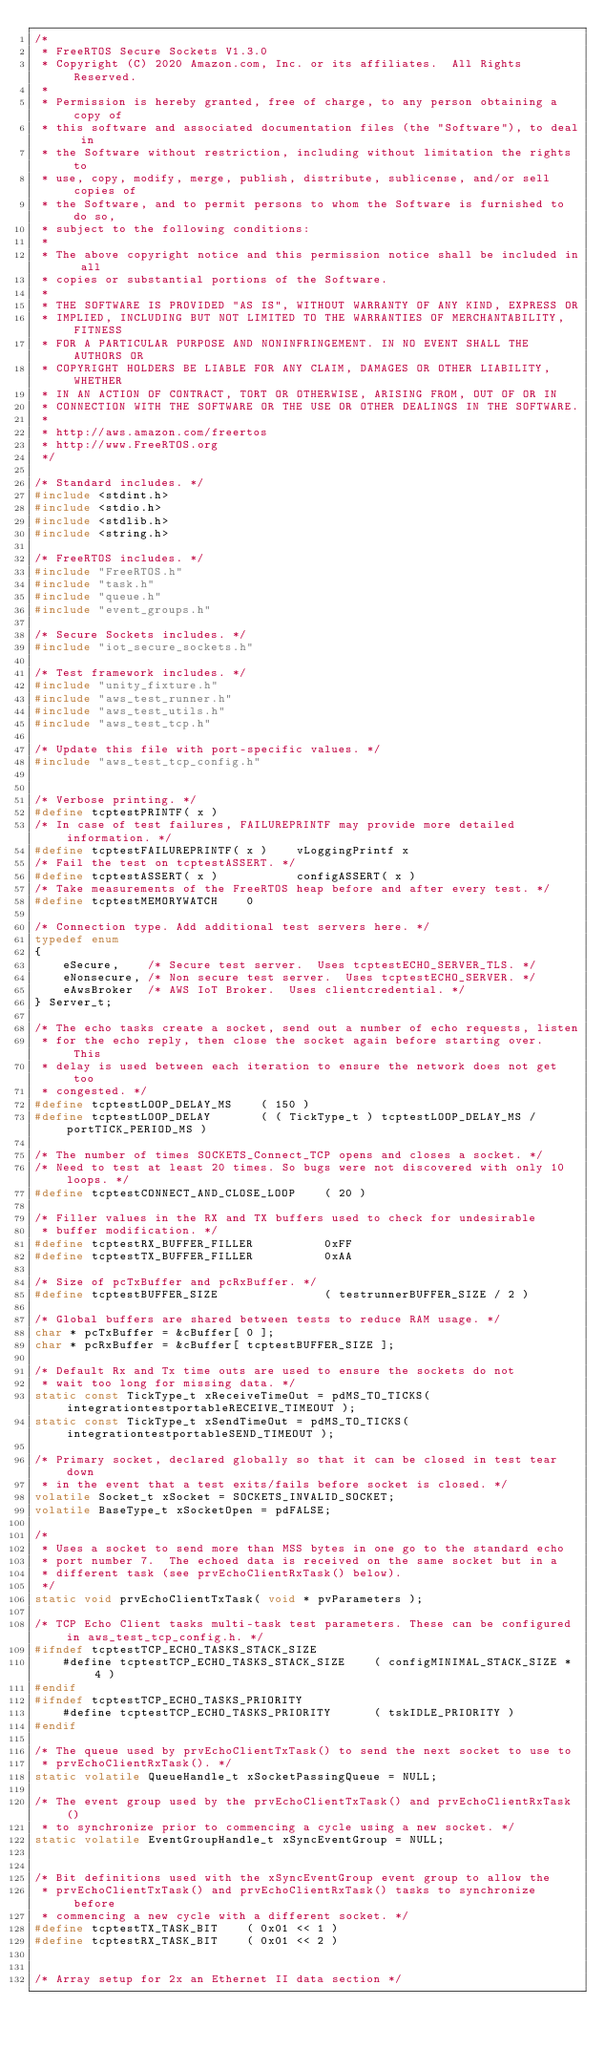Convert code to text. <code><loc_0><loc_0><loc_500><loc_500><_C_>/*
 * FreeRTOS Secure Sockets V1.3.0
 * Copyright (C) 2020 Amazon.com, Inc. or its affiliates.  All Rights Reserved.
 *
 * Permission is hereby granted, free of charge, to any person obtaining a copy of
 * this software and associated documentation files (the "Software"), to deal in
 * the Software without restriction, including without limitation the rights to
 * use, copy, modify, merge, publish, distribute, sublicense, and/or sell copies of
 * the Software, and to permit persons to whom the Software is furnished to do so,
 * subject to the following conditions:
 *
 * The above copyright notice and this permission notice shall be included in all
 * copies or substantial portions of the Software.
 *
 * THE SOFTWARE IS PROVIDED "AS IS", WITHOUT WARRANTY OF ANY KIND, EXPRESS OR
 * IMPLIED, INCLUDING BUT NOT LIMITED TO THE WARRANTIES OF MERCHANTABILITY, FITNESS
 * FOR A PARTICULAR PURPOSE AND NONINFRINGEMENT. IN NO EVENT SHALL THE AUTHORS OR
 * COPYRIGHT HOLDERS BE LIABLE FOR ANY CLAIM, DAMAGES OR OTHER LIABILITY, WHETHER
 * IN AN ACTION OF CONTRACT, TORT OR OTHERWISE, ARISING FROM, OUT OF OR IN
 * CONNECTION WITH THE SOFTWARE OR THE USE OR OTHER DEALINGS IN THE SOFTWARE.
 *
 * http://aws.amazon.com/freertos
 * http://www.FreeRTOS.org
 */

/* Standard includes. */
#include <stdint.h>
#include <stdio.h>
#include <stdlib.h>
#include <string.h>

/* FreeRTOS includes. */
#include "FreeRTOS.h"
#include "task.h"
#include "queue.h"
#include "event_groups.h"

/* Secure Sockets includes. */
#include "iot_secure_sockets.h"

/* Test framework includes. */
#include "unity_fixture.h"
#include "aws_test_runner.h"
#include "aws_test_utils.h"
#include "aws_test_tcp.h"

/* Update this file with port-specific values. */
#include "aws_test_tcp_config.h"


/* Verbose printing. */
#define tcptestPRINTF( x )
/* In case of test failures, FAILUREPRINTF may provide more detailed information. */
#define tcptestFAILUREPRINTF( x )    vLoggingPrintf x
/* Fail the test on tcptestASSERT. */
#define tcptestASSERT( x )           configASSERT( x )
/* Take measurements of the FreeRTOS heap before and after every test. */
#define tcptestMEMORYWATCH    0

/* Connection type. Add additional test servers here. */
typedef enum
{
    eSecure,    /* Secure test server.  Uses tcptestECHO_SERVER_TLS. */
    eNonsecure, /* Non secure test server.  Uses tcptestECHO_SERVER. */
    eAwsBroker  /* AWS IoT Broker.  Uses clientcredential. */
} Server_t;

/* The echo tasks create a socket, send out a number of echo requests, listen
 * for the echo reply, then close the socket again before starting over.  This
 * delay is used between each iteration to ensure the network does not get too
 * congested. */
#define tcptestLOOP_DELAY_MS    ( 150 )
#define tcptestLOOP_DELAY       ( ( TickType_t ) tcptestLOOP_DELAY_MS / portTICK_PERIOD_MS )

/* The number of times SOCKETS_Connect_TCP opens and closes a socket. */
/* Need to test at least 20 times. So bugs were not discovered with only 10 loops. */
#define tcptestCONNECT_AND_CLOSE_LOOP    ( 20 )

/* Filler values in the RX and TX buffers used to check for undesirable
 * buffer modification. */
#define tcptestRX_BUFFER_FILLER          0xFF
#define tcptestTX_BUFFER_FILLER          0xAA

/* Size of pcTxBuffer and pcRxBuffer. */
#define tcptestBUFFER_SIZE               ( testrunnerBUFFER_SIZE / 2 )

/* Global buffers are shared between tests to reduce RAM usage. */
char * pcTxBuffer = &cBuffer[ 0 ];
char * pcRxBuffer = &cBuffer[ tcptestBUFFER_SIZE ];

/* Default Rx and Tx time outs are used to ensure the sockets do not
 * wait too long for missing data. */
static const TickType_t xReceiveTimeOut = pdMS_TO_TICKS( integrationtestportableRECEIVE_TIMEOUT );
static const TickType_t xSendTimeOut = pdMS_TO_TICKS( integrationtestportableSEND_TIMEOUT );

/* Primary socket, declared globally so that it can be closed in test tear down
 * in the event that a test exits/fails before socket is closed. */
volatile Socket_t xSocket = SOCKETS_INVALID_SOCKET;
volatile BaseType_t xSocketOpen = pdFALSE;

/*
 * Uses a socket to send more than MSS bytes in one go to the standard echo
 * port number 7.  The echoed data is received on the same socket but in a
 * different task (see prvEchoClientRxTask() below).
 */
static void prvEchoClientTxTask( void * pvParameters );

/* TCP Echo Client tasks multi-task test parameters. These can be configured in aws_test_tcp_config.h. */
#ifndef tcptestTCP_ECHO_TASKS_STACK_SIZE
    #define tcptestTCP_ECHO_TASKS_STACK_SIZE    ( configMINIMAL_STACK_SIZE * 4 )
#endif
#ifndef tcptestTCP_ECHO_TASKS_PRIORITY
    #define tcptestTCP_ECHO_TASKS_PRIORITY      ( tskIDLE_PRIORITY )
#endif

/* The queue used by prvEchoClientTxTask() to send the next socket to use to
 * prvEchoClientRxTask(). */
static volatile QueueHandle_t xSocketPassingQueue = NULL;

/* The event group used by the prvEchoClientTxTask() and prvEchoClientRxTask()
 * to synchronize prior to commencing a cycle using a new socket. */
static volatile EventGroupHandle_t xSyncEventGroup = NULL;


/* Bit definitions used with the xSyncEventGroup event group to allow the
 * prvEchoClientTxTask() and prvEchoClientRxTask() tasks to synchronize before
 * commencing a new cycle with a different socket. */
#define tcptestTX_TASK_BIT    ( 0x01 << 1 )
#define tcptestRX_TASK_BIT    ( 0x01 << 2 )


/* Array setup for 2x an Ethernet II data section */</code> 